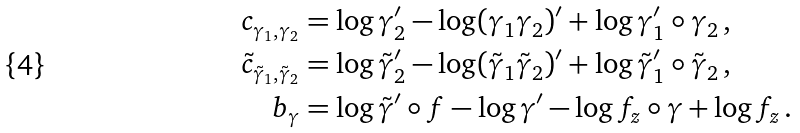Convert formula to latex. <formula><loc_0><loc_0><loc_500><loc_500>c _ { \gamma _ { 1 } , \gamma _ { 2 } } & = \log \gamma _ { 2 } ^ { \prime } - \log ( \gamma _ { 1 } \gamma _ { 2 } ) ^ { \prime } + \log \gamma _ { 1 } ^ { \prime } \circ \gamma _ { 2 } \, , \\ \tilde { c } _ { \tilde { \gamma } _ { 1 } , \tilde { \gamma } _ { 2 } } & = \log \tilde { \gamma } _ { 2 } ^ { \prime } - \log ( \tilde { \gamma } _ { 1 } \tilde { \gamma } _ { 2 } ) ^ { \prime } + \log \tilde { \gamma } _ { 1 } ^ { \prime } \circ \tilde { \gamma } _ { 2 } \, , \\ b _ { \gamma } & = \log \tilde { \gamma } ^ { \prime } \circ f - \log \gamma ^ { \prime } - \log f _ { z } \circ \gamma + \log f _ { z } \, .</formula> 